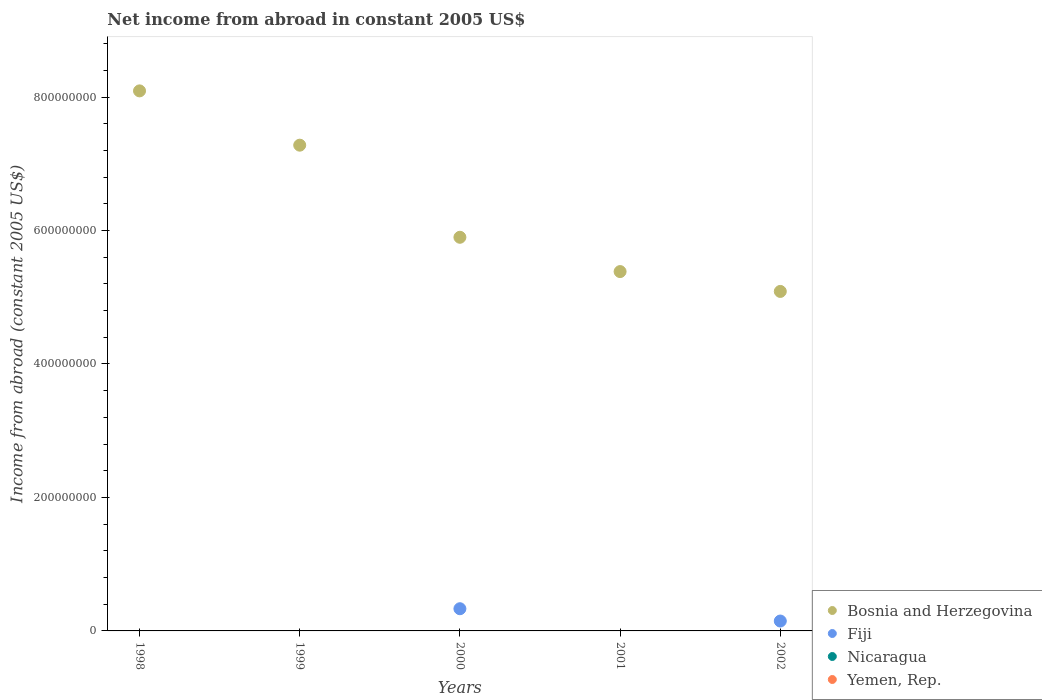Is the number of dotlines equal to the number of legend labels?
Your answer should be compact. No. What is the net income from abroad in Nicaragua in 2000?
Offer a terse response. 0. Across all years, what is the maximum net income from abroad in Bosnia and Herzegovina?
Ensure brevity in your answer.  8.09e+08. In which year was the net income from abroad in Fiji maximum?
Give a very brief answer. 2000. What is the total net income from abroad in Nicaragua in the graph?
Provide a short and direct response. 0. What is the difference between the net income from abroad in Bosnia and Herzegovina in 1999 and that in 2001?
Your answer should be very brief. 1.89e+08. What is the average net income from abroad in Fiji per year?
Offer a terse response. 9.62e+06. In the year 2002, what is the difference between the net income from abroad in Fiji and net income from abroad in Bosnia and Herzegovina?
Make the answer very short. -4.94e+08. What is the ratio of the net income from abroad in Bosnia and Herzegovina in 2001 to that in 2002?
Your answer should be compact. 1.06. What is the difference between the highest and the second highest net income from abroad in Bosnia and Herzegovina?
Ensure brevity in your answer.  8.14e+07. What is the difference between the highest and the lowest net income from abroad in Bosnia and Herzegovina?
Keep it short and to the point. 3.01e+08. In how many years, is the net income from abroad in Fiji greater than the average net income from abroad in Fiji taken over all years?
Keep it short and to the point. 2. Is the sum of the net income from abroad in Bosnia and Herzegovina in 2000 and 2001 greater than the maximum net income from abroad in Nicaragua across all years?
Your response must be concise. Yes. Is it the case that in every year, the sum of the net income from abroad in Yemen, Rep. and net income from abroad in Bosnia and Herzegovina  is greater than the sum of net income from abroad in Nicaragua and net income from abroad in Fiji?
Ensure brevity in your answer.  No. Is it the case that in every year, the sum of the net income from abroad in Bosnia and Herzegovina and net income from abroad in Fiji  is greater than the net income from abroad in Nicaragua?
Make the answer very short. Yes. How many years are there in the graph?
Provide a succinct answer. 5. Does the graph contain grids?
Give a very brief answer. No. How many legend labels are there?
Ensure brevity in your answer.  4. How are the legend labels stacked?
Give a very brief answer. Vertical. What is the title of the graph?
Offer a terse response. Net income from abroad in constant 2005 US$. Does "Suriname" appear as one of the legend labels in the graph?
Your answer should be compact. No. What is the label or title of the X-axis?
Make the answer very short. Years. What is the label or title of the Y-axis?
Your answer should be very brief. Income from abroad (constant 2005 US$). What is the Income from abroad (constant 2005 US$) of Bosnia and Herzegovina in 1998?
Provide a short and direct response. 8.09e+08. What is the Income from abroad (constant 2005 US$) in Fiji in 1998?
Provide a short and direct response. 0. What is the Income from abroad (constant 2005 US$) of Nicaragua in 1998?
Your answer should be compact. 0. What is the Income from abroad (constant 2005 US$) of Yemen, Rep. in 1998?
Offer a very short reply. 0. What is the Income from abroad (constant 2005 US$) of Bosnia and Herzegovina in 1999?
Provide a short and direct response. 7.28e+08. What is the Income from abroad (constant 2005 US$) in Fiji in 1999?
Your response must be concise. 0. What is the Income from abroad (constant 2005 US$) of Bosnia and Herzegovina in 2000?
Give a very brief answer. 5.90e+08. What is the Income from abroad (constant 2005 US$) in Fiji in 2000?
Your response must be concise. 3.33e+07. What is the Income from abroad (constant 2005 US$) in Nicaragua in 2000?
Your response must be concise. 0. What is the Income from abroad (constant 2005 US$) of Bosnia and Herzegovina in 2001?
Keep it short and to the point. 5.38e+08. What is the Income from abroad (constant 2005 US$) in Bosnia and Herzegovina in 2002?
Keep it short and to the point. 5.09e+08. What is the Income from abroad (constant 2005 US$) in Fiji in 2002?
Ensure brevity in your answer.  1.48e+07. Across all years, what is the maximum Income from abroad (constant 2005 US$) of Bosnia and Herzegovina?
Your answer should be compact. 8.09e+08. Across all years, what is the maximum Income from abroad (constant 2005 US$) in Fiji?
Your response must be concise. 3.33e+07. Across all years, what is the minimum Income from abroad (constant 2005 US$) of Bosnia and Herzegovina?
Your answer should be compact. 5.09e+08. Across all years, what is the minimum Income from abroad (constant 2005 US$) in Fiji?
Your response must be concise. 0. What is the total Income from abroad (constant 2005 US$) of Bosnia and Herzegovina in the graph?
Offer a terse response. 3.17e+09. What is the total Income from abroad (constant 2005 US$) in Fiji in the graph?
Provide a short and direct response. 4.81e+07. What is the total Income from abroad (constant 2005 US$) in Nicaragua in the graph?
Offer a very short reply. 0. What is the total Income from abroad (constant 2005 US$) in Yemen, Rep. in the graph?
Your response must be concise. 0. What is the difference between the Income from abroad (constant 2005 US$) in Bosnia and Herzegovina in 1998 and that in 1999?
Keep it short and to the point. 8.14e+07. What is the difference between the Income from abroad (constant 2005 US$) in Bosnia and Herzegovina in 1998 and that in 2000?
Offer a very short reply. 2.19e+08. What is the difference between the Income from abroad (constant 2005 US$) in Bosnia and Herzegovina in 1998 and that in 2001?
Make the answer very short. 2.71e+08. What is the difference between the Income from abroad (constant 2005 US$) of Bosnia and Herzegovina in 1998 and that in 2002?
Provide a succinct answer. 3.01e+08. What is the difference between the Income from abroad (constant 2005 US$) of Bosnia and Herzegovina in 1999 and that in 2000?
Offer a very short reply. 1.38e+08. What is the difference between the Income from abroad (constant 2005 US$) in Bosnia and Herzegovina in 1999 and that in 2001?
Keep it short and to the point. 1.89e+08. What is the difference between the Income from abroad (constant 2005 US$) of Bosnia and Herzegovina in 1999 and that in 2002?
Offer a terse response. 2.19e+08. What is the difference between the Income from abroad (constant 2005 US$) of Bosnia and Herzegovina in 2000 and that in 2001?
Provide a succinct answer. 5.14e+07. What is the difference between the Income from abroad (constant 2005 US$) of Bosnia and Herzegovina in 2000 and that in 2002?
Offer a very short reply. 8.11e+07. What is the difference between the Income from abroad (constant 2005 US$) of Fiji in 2000 and that in 2002?
Give a very brief answer. 1.84e+07. What is the difference between the Income from abroad (constant 2005 US$) of Bosnia and Herzegovina in 2001 and that in 2002?
Your answer should be very brief. 2.97e+07. What is the difference between the Income from abroad (constant 2005 US$) in Bosnia and Herzegovina in 1998 and the Income from abroad (constant 2005 US$) in Fiji in 2000?
Offer a very short reply. 7.76e+08. What is the difference between the Income from abroad (constant 2005 US$) in Bosnia and Herzegovina in 1998 and the Income from abroad (constant 2005 US$) in Fiji in 2002?
Ensure brevity in your answer.  7.94e+08. What is the difference between the Income from abroad (constant 2005 US$) of Bosnia and Herzegovina in 1999 and the Income from abroad (constant 2005 US$) of Fiji in 2000?
Your answer should be very brief. 6.95e+08. What is the difference between the Income from abroad (constant 2005 US$) in Bosnia and Herzegovina in 1999 and the Income from abroad (constant 2005 US$) in Fiji in 2002?
Ensure brevity in your answer.  7.13e+08. What is the difference between the Income from abroad (constant 2005 US$) in Bosnia and Herzegovina in 2000 and the Income from abroad (constant 2005 US$) in Fiji in 2002?
Keep it short and to the point. 5.75e+08. What is the difference between the Income from abroad (constant 2005 US$) of Bosnia and Herzegovina in 2001 and the Income from abroad (constant 2005 US$) of Fiji in 2002?
Make the answer very short. 5.24e+08. What is the average Income from abroad (constant 2005 US$) of Bosnia and Herzegovina per year?
Your answer should be compact. 6.35e+08. What is the average Income from abroad (constant 2005 US$) in Fiji per year?
Keep it short and to the point. 9.62e+06. What is the average Income from abroad (constant 2005 US$) in Yemen, Rep. per year?
Your answer should be compact. 0. In the year 2000, what is the difference between the Income from abroad (constant 2005 US$) of Bosnia and Herzegovina and Income from abroad (constant 2005 US$) of Fiji?
Provide a succinct answer. 5.57e+08. In the year 2002, what is the difference between the Income from abroad (constant 2005 US$) in Bosnia and Herzegovina and Income from abroad (constant 2005 US$) in Fiji?
Provide a short and direct response. 4.94e+08. What is the ratio of the Income from abroad (constant 2005 US$) of Bosnia and Herzegovina in 1998 to that in 1999?
Your answer should be compact. 1.11. What is the ratio of the Income from abroad (constant 2005 US$) of Bosnia and Herzegovina in 1998 to that in 2000?
Offer a terse response. 1.37. What is the ratio of the Income from abroad (constant 2005 US$) of Bosnia and Herzegovina in 1998 to that in 2001?
Your answer should be compact. 1.5. What is the ratio of the Income from abroad (constant 2005 US$) of Bosnia and Herzegovina in 1998 to that in 2002?
Provide a short and direct response. 1.59. What is the ratio of the Income from abroad (constant 2005 US$) of Bosnia and Herzegovina in 1999 to that in 2000?
Provide a short and direct response. 1.23. What is the ratio of the Income from abroad (constant 2005 US$) in Bosnia and Herzegovina in 1999 to that in 2001?
Keep it short and to the point. 1.35. What is the ratio of the Income from abroad (constant 2005 US$) of Bosnia and Herzegovina in 1999 to that in 2002?
Provide a short and direct response. 1.43. What is the ratio of the Income from abroad (constant 2005 US$) in Bosnia and Herzegovina in 2000 to that in 2001?
Provide a short and direct response. 1.1. What is the ratio of the Income from abroad (constant 2005 US$) in Bosnia and Herzegovina in 2000 to that in 2002?
Your response must be concise. 1.16. What is the ratio of the Income from abroad (constant 2005 US$) in Fiji in 2000 to that in 2002?
Ensure brevity in your answer.  2.25. What is the ratio of the Income from abroad (constant 2005 US$) in Bosnia and Herzegovina in 2001 to that in 2002?
Your answer should be very brief. 1.06. What is the difference between the highest and the second highest Income from abroad (constant 2005 US$) of Bosnia and Herzegovina?
Offer a very short reply. 8.14e+07. What is the difference between the highest and the lowest Income from abroad (constant 2005 US$) of Bosnia and Herzegovina?
Your answer should be very brief. 3.01e+08. What is the difference between the highest and the lowest Income from abroad (constant 2005 US$) of Fiji?
Give a very brief answer. 3.33e+07. 